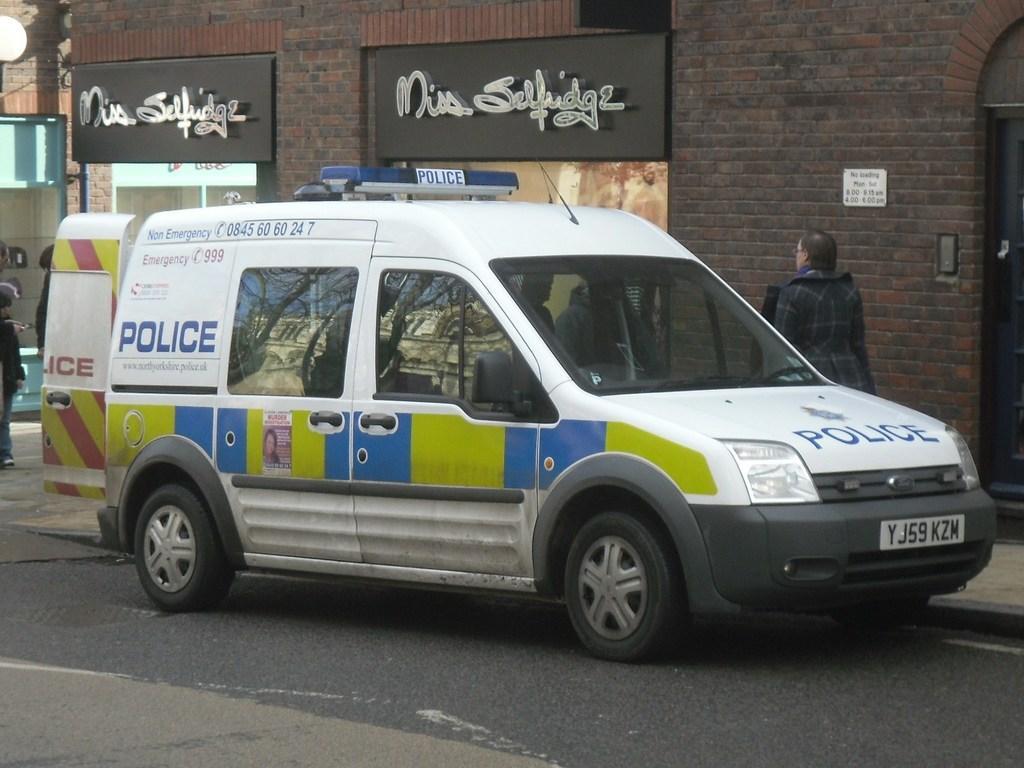In one or two sentences, can you explain what this image depicts? In this image, we can see a vehicle in front of the wall. There are boards at the top of the image. There is a person on the left and on the right side of the image. 